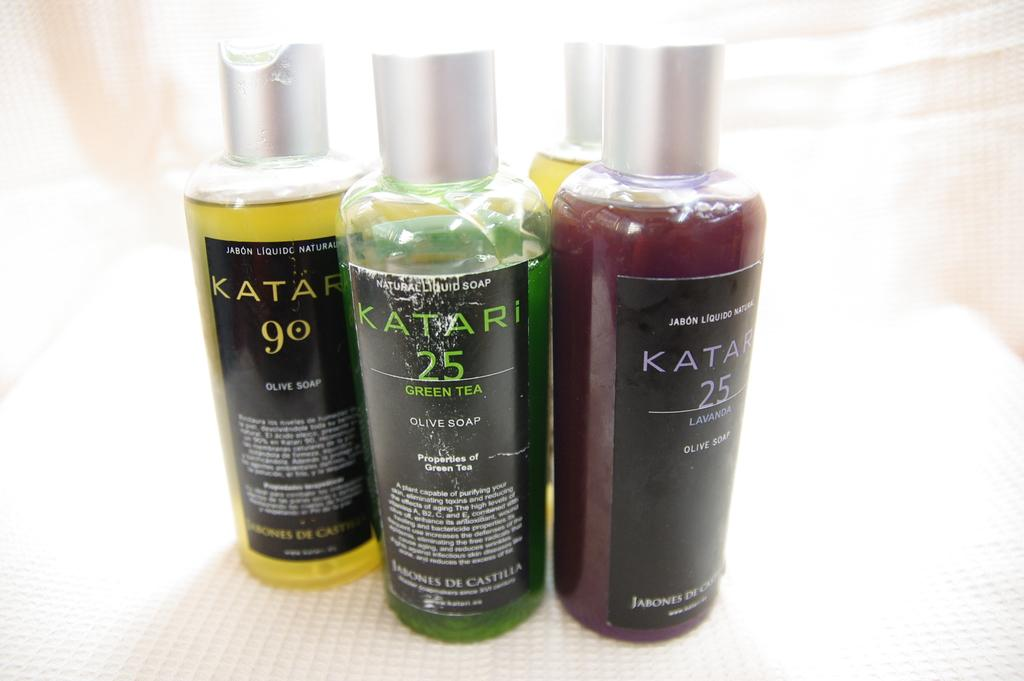<image>
Provide a brief description of the given image. Three different coloured bottles from the brand Katari. 